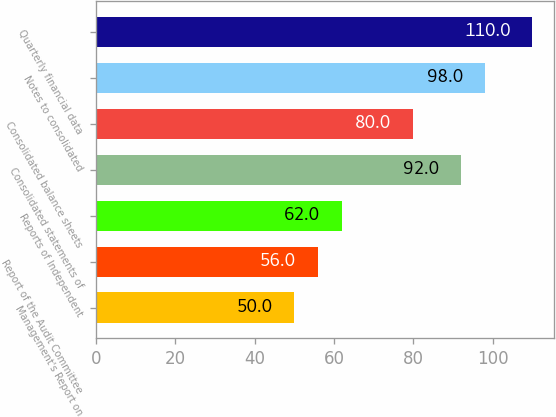Convert chart. <chart><loc_0><loc_0><loc_500><loc_500><bar_chart><fcel>Management's Report on<fcel>Report of the Audit Committee<fcel>Reports of Independent<fcel>Consolidated statements of<fcel>Consolidated balance sheets<fcel>Notes to consolidated<fcel>Quarterly financial data<nl><fcel>50<fcel>56<fcel>62<fcel>92<fcel>80<fcel>98<fcel>110<nl></chart> 